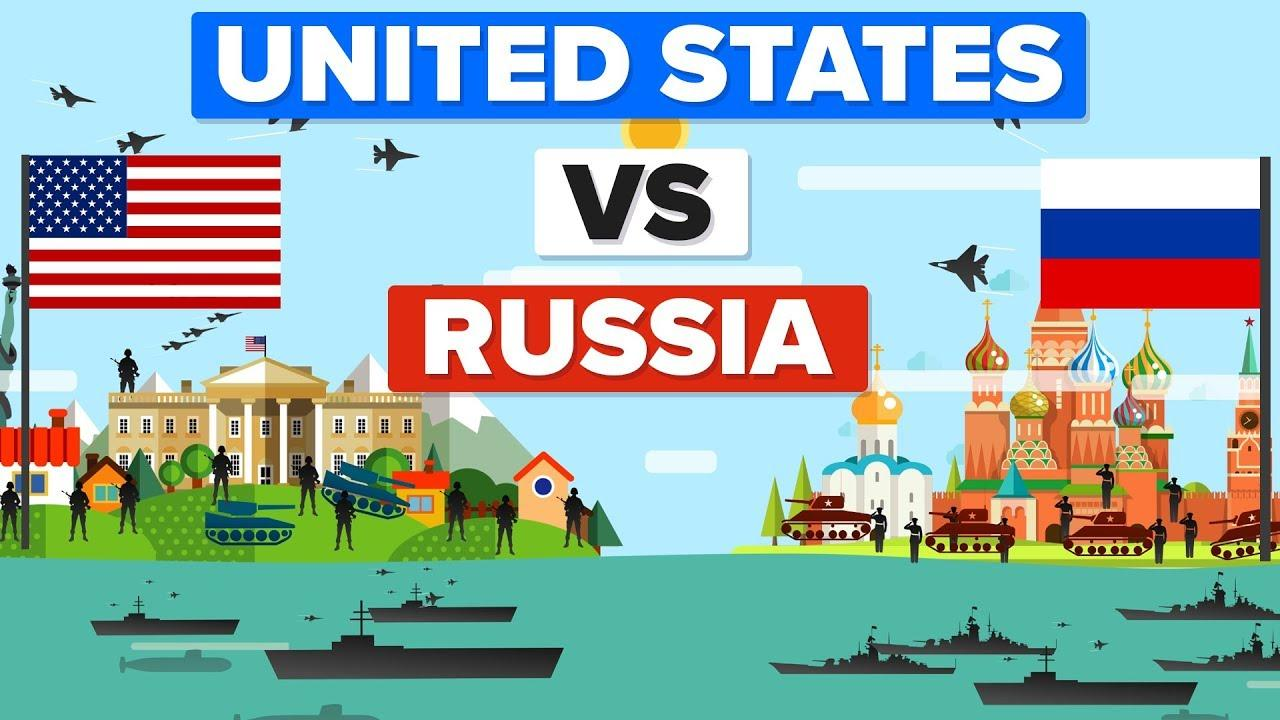Identify some key points in this picture. It is estimated that the Russian army currently has approximately 9 soldiers. There are approximately 1,280,000 soldiers currently serving in the United States Army. 